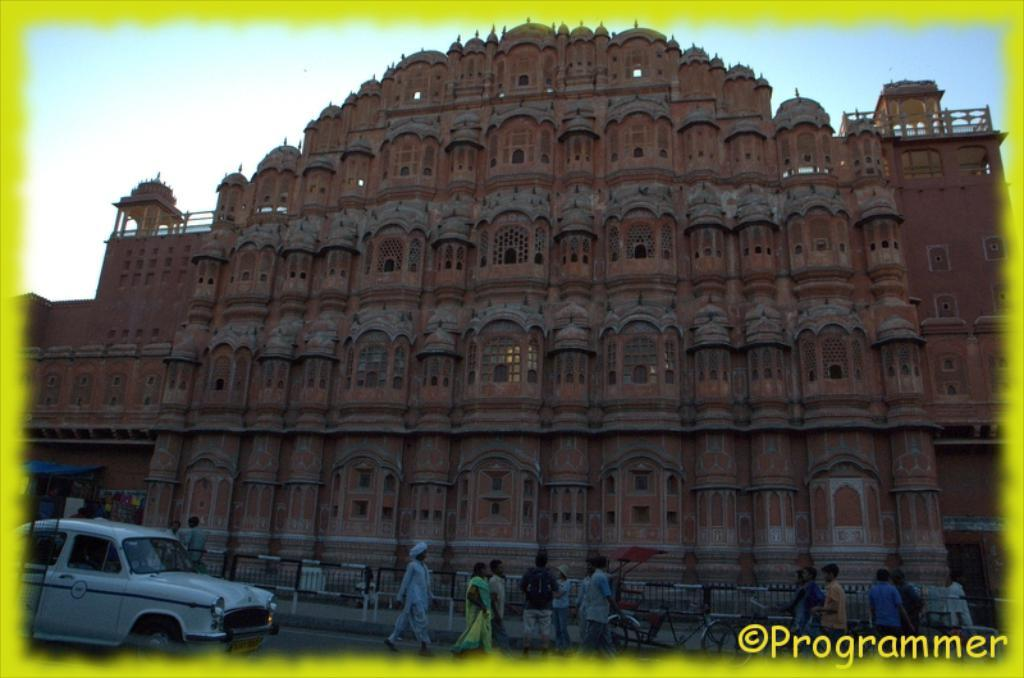What type of editing has been done to the image? The image is edited, but the specific type of editing is not mentioned in the facts. What is the main subject in the center of the image? There is a palace in the center of the image. Who or what can be seen at the bottom of the image? There are people at the bottom of the image. What mode of transportation is present in the image? There is a car in the image. What color are the crayons used to draw the palace in the image? There are no crayons present in the image; it is a photograph or digitally edited image of a palace. 